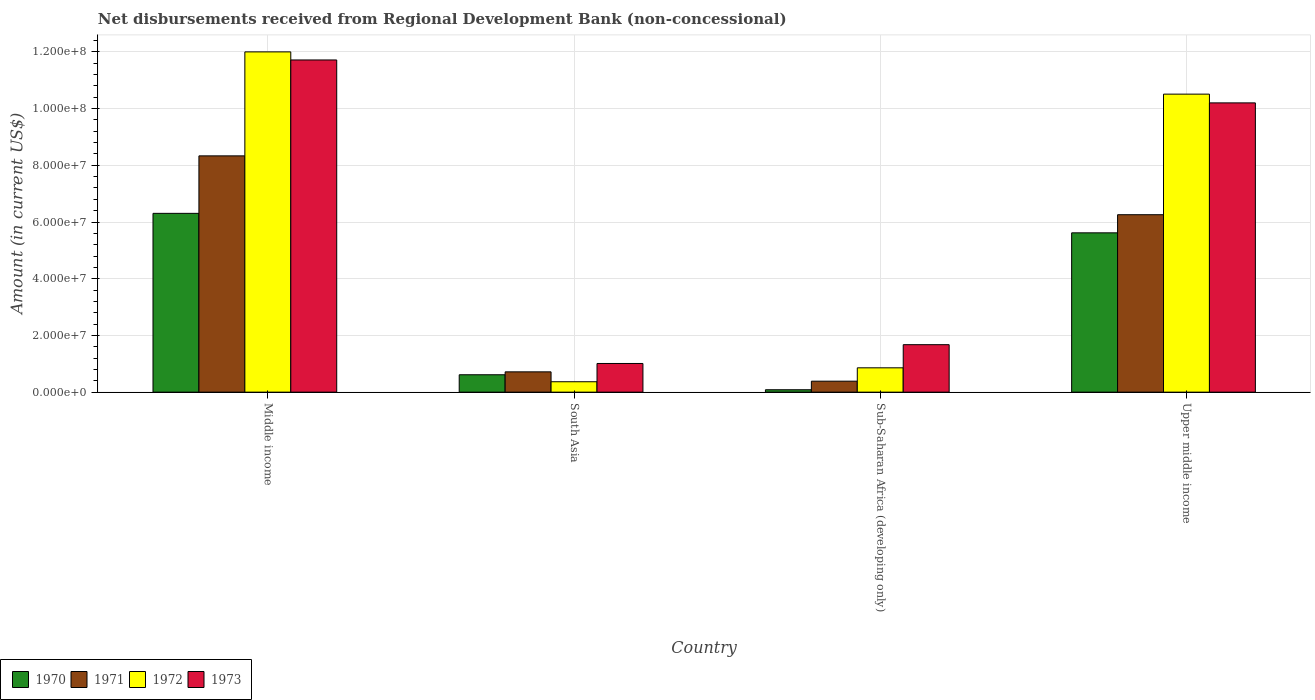How many groups of bars are there?
Provide a succinct answer. 4. Are the number of bars per tick equal to the number of legend labels?
Provide a short and direct response. Yes. Are the number of bars on each tick of the X-axis equal?
Your answer should be compact. Yes. What is the label of the 1st group of bars from the left?
Your response must be concise. Middle income. What is the amount of disbursements received from Regional Development Bank in 1971 in Upper middle income?
Your response must be concise. 6.26e+07. Across all countries, what is the maximum amount of disbursements received from Regional Development Bank in 1971?
Your answer should be very brief. 8.33e+07. Across all countries, what is the minimum amount of disbursements received from Regional Development Bank in 1973?
Provide a succinct answer. 1.01e+07. In which country was the amount of disbursements received from Regional Development Bank in 1973 minimum?
Make the answer very short. South Asia. What is the total amount of disbursements received from Regional Development Bank in 1973 in the graph?
Your answer should be very brief. 2.46e+08. What is the difference between the amount of disbursements received from Regional Development Bank in 1971 in South Asia and that in Upper middle income?
Give a very brief answer. -5.54e+07. What is the difference between the amount of disbursements received from Regional Development Bank in 1970 in Sub-Saharan Africa (developing only) and the amount of disbursements received from Regional Development Bank in 1973 in South Asia?
Your response must be concise. -9.26e+06. What is the average amount of disbursements received from Regional Development Bank in 1970 per country?
Ensure brevity in your answer.  3.16e+07. What is the difference between the amount of disbursements received from Regional Development Bank of/in 1970 and amount of disbursements received from Regional Development Bank of/in 1971 in Middle income?
Your response must be concise. -2.03e+07. In how many countries, is the amount of disbursements received from Regional Development Bank in 1971 greater than 40000000 US$?
Keep it short and to the point. 2. What is the ratio of the amount of disbursements received from Regional Development Bank in 1972 in Middle income to that in South Asia?
Make the answer very short. 32.71. Is the difference between the amount of disbursements received from Regional Development Bank in 1970 in Middle income and South Asia greater than the difference between the amount of disbursements received from Regional Development Bank in 1971 in Middle income and South Asia?
Your response must be concise. No. What is the difference between the highest and the second highest amount of disbursements received from Regional Development Bank in 1973?
Provide a short and direct response. 1.51e+07. What is the difference between the highest and the lowest amount of disbursements received from Regional Development Bank in 1973?
Give a very brief answer. 1.07e+08. Is the sum of the amount of disbursements received from Regional Development Bank in 1973 in South Asia and Sub-Saharan Africa (developing only) greater than the maximum amount of disbursements received from Regional Development Bank in 1971 across all countries?
Your response must be concise. No. What does the 4th bar from the left in Sub-Saharan Africa (developing only) represents?
Your answer should be compact. 1973. Is it the case that in every country, the sum of the amount of disbursements received from Regional Development Bank in 1973 and amount of disbursements received from Regional Development Bank in 1972 is greater than the amount of disbursements received from Regional Development Bank in 1971?
Ensure brevity in your answer.  Yes. How many bars are there?
Make the answer very short. 16. Are the values on the major ticks of Y-axis written in scientific E-notation?
Make the answer very short. Yes. Does the graph contain grids?
Provide a short and direct response. Yes. What is the title of the graph?
Ensure brevity in your answer.  Net disbursements received from Regional Development Bank (non-concessional). What is the label or title of the Y-axis?
Ensure brevity in your answer.  Amount (in current US$). What is the Amount (in current US$) of 1970 in Middle income?
Keep it short and to the point. 6.31e+07. What is the Amount (in current US$) in 1971 in Middle income?
Your answer should be compact. 8.33e+07. What is the Amount (in current US$) in 1972 in Middle income?
Provide a short and direct response. 1.20e+08. What is the Amount (in current US$) in 1973 in Middle income?
Give a very brief answer. 1.17e+08. What is the Amount (in current US$) in 1970 in South Asia?
Your answer should be very brief. 6.13e+06. What is the Amount (in current US$) in 1971 in South Asia?
Your response must be concise. 7.16e+06. What is the Amount (in current US$) of 1972 in South Asia?
Give a very brief answer. 3.67e+06. What is the Amount (in current US$) in 1973 in South Asia?
Offer a very short reply. 1.01e+07. What is the Amount (in current US$) in 1970 in Sub-Saharan Africa (developing only)?
Your answer should be very brief. 8.50e+05. What is the Amount (in current US$) of 1971 in Sub-Saharan Africa (developing only)?
Provide a short and direct response. 3.87e+06. What is the Amount (in current US$) in 1972 in Sub-Saharan Africa (developing only)?
Give a very brief answer. 8.58e+06. What is the Amount (in current US$) of 1973 in Sub-Saharan Africa (developing only)?
Give a very brief answer. 1.67e+07. What is the Amount (in current US$) in 1970 in Upper middle income?
Provide a succinct answer. 5.62e+07. What is the Amount (in current US$) of 1971 in Upper middle income?
Your response must be concise. 6.26e+07. What is the Amount (in current US$) in 1972 in Upper middle income?
Your response must be concise. 1.05e+08. What is the Amount (in current US$) of 1973 in Upper middle income?
Give a very brief answer. 1.02e+08. Across all countries, what is the maximum Amount (in current US$) of 1970?
Ensure brevity in your answer.  6.31e+07. Across all countries, what is the maximum Amount (in current US$) in 1971?
Ensure brevity in your answer.  8.33e+07. Across all countries, what is the maximum Amount (in current US$) in 1972?
Give a very brief answer. 1.20e+08. Across all countries, what is the maximum Amount (in current US$) of 1973?
Your answer should be very brief. 1.17e+08. Across all countries, what is the minimum Amount (in current US$) of 1970?
Make the answer very short. 8.50e+05. Across all countries, what is the minimum Amount (in current US$) in 1971?
Offer a terse response. 3.87e+06. Across all countries, what is the minimum Amount (in current US$) in 1972?
Offer a very short reply. 3.67e+06. Across all countries, what is the minimum Amount (in current US$) in 1973?
Give a very brief answer. 1.01e+07. What is the total Amount (in current US$) of 1970 in the graph?
Your response must be concise. 1.26e+08. What is the total Amount (in current US$) in 1971 in the graph?
Keep it short and to the point. 1.57e+08. What is the total Amount (in current US$) of 1972 in the graph?
Provide a short and direct response. 2.37e+08. What is the total Amount (in current US$) of 1973 in the graph?
Your response must be concise. 2.46e+08. What is the difference between the Amount (in current US$) in 1970 in Middle income and that in South Asia?
Provide a succinct answer. 5.69e+07. What is the difference between the Amount (in current US$) of 1971 in Middle income and that in South Asia?
Your response must be concise. 7.62e+07. What is the difference between the Amount (in current US$) in 1972 in Middle income and that in South Asia?
Your response must be concise. 1.16e+08. What is the difference between the Amount (in current US$) of 1973 in Middle income and that in South Asia?
Your answer should be very brief. 1.07e+08. What is the difference between the Amount (in current US$) in 1970 in Middle income and that in Sub-Saharan Africa (developing only)?
Give a very brief answer. 6.22e+07. What is the difference between the Amount (in current US$) in 1971 in Middle income and that in Sub-Saharan Africa (developing only)?
Your response must be concise. 7.95e+07. What is the difference between the Amount (in current US$) in 1972 in Middle income and that in Sub-Saharan Africa (developing only)?
Your response must be concise. 1.11e+08. What is the difference between the Amount (in current US$) in 1973 in Middle income and that in Sub-Saharan Africa (developing only)?
Your answer should be very brief. 1.00e+08. What is the difference between the Amount (in current US$) in 1970 in Middle income and that in Upper middle income?
Make the answer very short. 6.87e+06. What is the difference between the Amount (in current US$) of 1971 in Middle income and that in Upper middle income?
Make the answer very short. 2.08e+07. What is the difference between the Amount (in current US$) in 1972 in Middle income and that in Upper middle income?
Keep it short and to the point. 1.49e+07. What is the difference between the Amount (in current US$) of 1973 in Middle income and that in Upper middle income?
Your answer should be compact. 1.51e+07. What is the difference between the Amount (in current US$) of 1970 in South Asia and that in Sub-Saharan Africa (developing only)?
Your answer should be very brief. 5.28e+06. What is the difference between the Amount (in current US$) in 1971 in South Asia and that in Sub-Saharan Africa (developing only)?
Offer a very short reply. 3.29e+06. What is the difference between the Amount (in current US$) of 1972 in South Asia and that in Sub-Saharan Africa (developing only)?
Give a very brief answer. -4.91e+06. What is the difference between the Amount (in current US$) of 1973 in South Asia and that in Sub-Saharan Africa (developing only)?
Your answer should be compact. -6.63e+06. What is the difference between the Amount (in current US$) in 1970 in South Asia and that in Upper middle income?
Give a very brief answer. -5.01e+07. What is the difference between the Amount (in current US$) in 1971 in South Asia and that in Upper middle income?
Offer a terse response. -5.54e+07. What is the difference between the Amount (in current US$) of 1972 in South Asia and that in Upper middle income?
Make the answer very short. -1.01e+08. What is the difference between the Amount (in current US$) of 1973 in South Asia and that in Upper middle income?
Offer a very short reply. -9.19e+07. What is the difference between the Amount (in current US$) of 1970 in Sub-Saharan Africa (developing only) and that in Upper middle income?
Offer a very short reply. -5.53e+07. What is the difference between the Amount (in current US$) of 1971 in Sub-Saharan Africa (developing only) and that in Upper middle income?
Ensure brevity in your answer.  -5.87e+07. What is the difference between the Amount (in current US$) of 1972 in Sub-Saharan Africa (developing only) and that in Upper middle income?
Keep it short and to the point. -9.65e+07. What is the difference between the Amount (in current US$) in 1973 in Sub-Saharan Africa (developing only) and that in Upper middle income?
Offer a terse response. -8.53e+07. What is the difference between the Amount (in current US$) in 1970 in Middle income and the Amount (in current US$) in 1971 in South Asia?
Your answer should be compact. 5.59e+07. What is the difference between the Amount (in current US$) of 1970 in Middle income and the Amount (in current US$) of 1972 in South Asia?
Ensure brevity in your answer.  5.94e+07. What is the difference between the Amount (in current US$) of 1970 in Middle income and the Amount (in current US$) of 1973 in South Asia?
Make the answer very short. 5.29e+07. What is the difference between the Amount (in current US$) of 1971 in Middle income and the Amount (in current US$) of 1972 in South Asia?
Ensure brevity in your answer.  7.97e+07. What is the difference between the Amount (in current US$) in 1971 in Middle income and the Amount (in current US$) in 1973 in South Asia?
Keep it short and to the point. 7.32e+07. What is the difference between the Amount (in current US$) of 1972 in Middle income and the Amount (in current US$) of 1973 in South Asia?
Give a very brief answer. 1.10e+08. What is the difference between the Amount (in current US$) of 1970 in Middle income and the Amount (in current US$) of 1971 in Sub-Saharan Africa (developing only)?
Ensure brevity in your answer.  5.92e+07. What is the difference between the Amount (in current US$) in 1970 in Middle income and the Amount (in current US$) in 1972 in Sub-Saharan Africa (developing only)?
Give a very brief answer. 5.45e+07. What is the difference between the Amount (in current US$) in 1970 in Middle income and the Amount (in current US$) in 1973 in Sub-Saharan Africa (developing only)?
Make the answer very short. 4.63e+07. What is the difference between the Amount (in current US$) of 1971 in Middle income and the Amount (in current US$) of 1972 in Sub-Saharan Africa (developing only)?
Offer a terse response. 7.47e+07. What is the difference between the Amount (in current US$) in 1971 in Middle income and the Amount (in current US$) in 1973 in Sub-Saharan Africa (developing only)?
Provide a succinct answer. 6.66e+07. What is the difference between the Amount (in current US$) in 1972 in Middle income and the Amount (in current US$) in 1973 in Sub-Saharan Africa (developing only)?
Keep it short and to the point. 1.03e+08. What is the difference between the Amount (in current US$) in 1970 in Middle income and the Amount (in current US$) in 1971 in Upper middle income?
Keep it short and to the point. 4.82e+05. What is the difference between the Amount (in current US$) in 1970 in Middle income and the Amount (in current US$) in 1972 in Upper middle income?
Your response must be concise. -4.20e+07. What is the difference between the Amount (in current US$) of 1970 in Middle income and the Amount (in current US$) of 1973 in Upper middle income?
Ensure brevity in your answer.  -3.90e+07. What is the difference between the Amount (in current US$) in 1971 in Middle income and the Amount (in current US$) in 1972 in Upper middle income?
Give a very brief answer. -2.18e+07. What is the difference between the Amount (in current US$) in 1971 in Middle income and the Amount (in current US$) in 1973 in Upper middle income?
Your response must be concise. -1.87e+07. What is the difference between the Amount (in current US$) in 1972 in Middle income and the Amount (in current US$) in 1973 in Upper middle income?
Provide a short and direct response. 1.80e+07. What is the difference between the Amount (in current US$) in 1970 in South Asia and the Amount (in current US$) in 1971 in Sub-Saharan Africa (developing only)?
Provide a short and direct response. 2.26e+06. What is the difference between the Amount (in current US$) of 1970 in South Asia and the Amount (in current US$) of 1972 in Sub-Saharan Africa (developing only)?
Provide a short and direct response. -2.45e+06. What is the difference between the Amount (in current US$) in 1970 in South Asia and the Amount (in current US$) in 1973 in Sub-Saharan Africa (developing only)?
Provide a succinct answer. -1.06e+07. What is the difference between the Amount (in current US$) in 1971 in South Asia and the Amount (in current US$) in 1972 in Sub-Saharan Africa (developing only)?
Provide a short and direct response. -1.42e+06. What is the difference between the Amount (in current US$) in 1971 in South Asia and the Amount (in current US$) in 1973 in Sub-Saharan Africa (developing only)?
Ensure brevity in your answer.  -9.58e+06. What is the difference between the Amount (in current US$) in 1972 in South Asia and the Amount (in current US$) in 1973 in Sub-Saharan Africa (developing only)?
Offer a very short reply. -1.31e+07. What is the difference between the Amount (in current US$) in 1970 in South Asia and the Amount (in current US$) in 1971 in Upper middle income?
Give a very brief answer. -5.64e+07. What is the difference between the Amount (in current US$) of 1970 in South Asia and the Amount (in current US$) of 1972 in Upper middle income?
Give a very brief answer. -9.90e+07. What is the difference between the Amount (in current US$) of 1970 in South Asia and the Amount (in current US$) of 1973 in Upper middle income?
Your answer should be very brief. -9.59e+07. What is the difference between the Amount (in current US$) of 1971 in South Asia and the Amount (in current US$) of 1972 in Upper middle income?
Offer a terse response. -9.79e+07. What is the difference between the Amount (in current US$) of 1971 in South Asia and the Amount (in current US$) of 1973 in Upper middle income?
Ensure brevity in your answer.  -9.49e+07. What is the difference between the Amount (in current US$) in 1972 in South Asia and the Amount (in current US$) in 1973 in Upper middle income?
Offer a terse response. -9.83e+07. What is the difference between the Amount (in current US$) in 1970 in Sub-Saharan Africa (developing only) and the Amount (in current US$) in 1971 in Upper middle income?
Your answer should be very brief. -6.17e+07. What is the difference between the Amount (in current US$) of 1970 in Sub-Saharan Africa (developing only) and the Amount (in current US$) of 1972 in Upper middle income?
Provide a short and direct response. -1.04e+08. What is the difference between the Amount (in current US$) in 1970 in Sub-Saharan Africa (developing only) and the Amount (in current US$) in 1973 in Upper middle income?
Your answer should be compact. -1.01e+08. What is the difference between the Amount (in current US$) of 1971 in Sub-Saharan Africa (developing only) and the Amount (in current US$) of 1972 in Upper middle income?
Ensure brevity in your answer.  -1.01e+08. What is the difference between the Amount (in current US$) of 1971 in Sub-Saharan Africa (developing only) and the Amount (in current US$) of 1973 in Upper middle income?
Your answer should be compact. -9.81e+07. What is the difference between the Amount (in current US$) in 1972 in Sub-Saharan Africa (developing only) and the Amount (in current US$) in 1973 in Upper middle income?
Ensure brevity in your answer.  -9.34e+07. What is the average Amount (in current US$) of 1970 per country?
Offer a terse response. 3.16e+07. What is the average Amount (in current US$) in 1971 per country?
Your answer should be very brief. 3.92e+07. What is the average Amount (in current US$) of 1972 per country?
Provide a succinct answer. 5.93e+07. What is the average Amount (in current US$) of 1973 per country?
Make the answer very short. 6.15e+07. What is the difference between the Amount (in current US$) in 1970 and Amount (in current US$) in 1971 in Middle income?
Your response must be concise. -2.03e+07. What is the difference between the Amount (in current US$) in 1970 and Amount (in current US$) in 1972 in Middle income?
Ensure brevity in your answer.  -5.69e+07. What is the difference between the Amount (in current US$) of 1970 and Amount (in current US$) of 1973 in Middle income?
Provide a short and direct response. -5.41e+07. What is the difference between the Amount (in current US$) of 1971 and Amount (in current US$) of 1972 in Middle income?
Ensure brevity in your answer.  -3.67e+07. What is the difference between the Amount (in current US$) in 1971 and Amount (in current US$) in 1973 in Middle income?
Keep it short and to the point. -3.38e+07. What is the difference between the Amount (in current US$) of 1972 and Amount (in current US$) of 1973 in Middle income?
Your response must be concise. 2.85e+06. What is the difference between the Amount (in current US$) of 1970 and Amount (in current US$) of 1971 in South Asia?
Offer a very short reply. -1.02e+06. What is the difference between the Amount (in current US$) in 1970 and Amount (in current US$) in 1972 in South Asia?
Give a very brief answer. 2.46e+06. What is the difference between the Amount (in current US$) of 1970 and Amount (in current US$) of 1973 in South Asia?
Make the answer very short. -3.98e+06. What is the difference between the Amount (in current US$) in 1971 and Amount (in current US$) in 1972 in South Asia?
Give a very brief answer. 3.49e+06. What is the difference between the Amount (in current US$) in 1971 and Amount (in current US$) in 1973 in South Asia?
Make the answer very short. -2.95e+06. What is the difference between the Amount (in current US$) of 1972 and Amount (in current US$) of 1973 in South Asia?
Your answer should be very brief. -6.44e+06. What is the difference between the Amount (in current US$) of 1970 and Amount (in current US$) of 1971 in Sub-Saharan Africa (developing only)?
Keep it short and to the point. -3.02e+06. What is the difference between the Amount (in current US$) of 1970 and Amount (in current US$) of 1972 in Sub-Saharan Africa (developing only)?
Offer a terse response. -7.73e+06. What is the difference between the Amount (in current US$) of 1970 and Amount (in current US$) of 1973 in Sub-Saharan Africa (developing only)?
Give a very brief answer. -1.59e+07. What is the difference between the Amount (in current US$) in 1971 and Amount (in current US$) in 1972 in Sub-Saharan Africa (developing only)?
Your answer should be compact. -4.71e+06. What is the difference between the Amount (in current US$) in 1971 and Amount (in current US$) in 1973 in Sub-Saharan Africa (developing only)?
Offer a terse response. -1.29e+07. What is the difference between the Amount (in current US$) of 1972 and Amount (in current US$) of 1973 in Sub-Saharan Africa (developing only)?
Give a very brief answer. -8.16e+06. What is the difference between the Amount (in current US$) in 1970 and Amount (in current US$) in 1971 in Upper middle income?
Offer a very short reply. -6.39e+06. What is the difference between the Amount (in current US$) in 1970 and Amount (in current US$) in 1972 in Upper middle income?
Make the answer very short. -4.89e+07. What is the difference between the Amount (in current US$) in 1970 and Amount (in current US$) in 1973 in Upper middle income?
Offer a terse response. -4.58e+07. What is the difference between the Amount (in current US$) in 1971 and Amount (in current US$) in 1972 in Upper middle income?
Provide a short and direct response. -4.25e+07. What is the difference between the Amount (in current US$) of 1971 and Amount (in current US$) of 1973 in Upper middle income?
Provide a short and direct response. -3.94e+07. What is the difference between the Amount (in current US$) of 1972 and Amount (in current US$) of 1973 in Upper middle income?
Offer a very short reply. 3.08e+06. What is the ratio of the Amount (in current US$) of 1970 in Middle income to that in South Asia?
Make the answer very short. 10.28. What is the ratio of the Amount (in current US$) in 1971 in Middle income to that in South Asia?
Ensure brevity in your answer.  11.64. What is the ratio of the Amount (in current US$) of 1972 in Middle income to that in South Asia?
Offer a very short reply. 32.71. What is the ratio of the Amount (in current US$) of 1973 in Middle income to that in South Asia?
Provide a succinct answer. 11.58. What is the ratio of the Amount (in current US$) of 1970 in Middle income to that in Sub-Saharan Africa (developing only)?
Your answer should be very brief. 74.18. What is the ratio of the Amount (in current US$) of 1971 in Middle income to that in Sub-Saharan Africa (developing only)?
Your response must be concise. 21.54. What is the ratio of the Amount (in current US$) of 1972 in Middle income to that in Sub-Saharan Africa (developing only)?
Offer a very short reply. 13.98. What is the ratio of the Amount (in current US$) of 1973 in Middle income to that in Sub-Saharan Africa (developing only)?
Your answer should be very brief. 7. What is the ratio of the Amount (in current US$) of 1970 in Middle income to that in Upper middle income?
Your response must be concise. 1.12. What is the ratio of the Amount (in current US$) in 1971 in Middle income to that in Upper middle income?
Offer a terse response. 1.33. What is the ratio of the Amount (in current US$) in 1972 in Middle income to that in Upper middle income?
Your response must be concise. 1.14. What is the ratio of the Amount (in current US$) of 1973 in Middle income to that in Upper middle income?
Provide a succinct answer. 1.15. What is the ratio of the Amount (in current US$) of 1970 in South Asia to that in Sub-Saharan Africa (developing only)?
Provide a succinct answer. 7.22. What is the ratio of the Amount (in current US$) in 1971 in South Asia to that in Sub-Saharan Africa (developing only)?
Make the answer very short. 1.85. What is the ratio of the Amount (in current US$) in 1972 in South Asia to that in Sub-Saharan Africa (developing only)?
Give a very brief answer. 0.43. What is the ratio of the Amount (in current US$) in 1973 in South Asia to that in Sub-Saharan Africa (developing only)?
Provide a short and direct response. 0.6. What is the ratio of the Amount (in current US$) in 1970 in South Asia to that in Upper middle income?
Offer a very short reply. 0.11. What is the ratio of the Amount (in current US$) in 1971 in South Asia to that in Upper middle income?
Give a very brief answer. 0.11. What is the ratio of the Amount (in current US$) in 1972 in South Asia to that in Upper middle income?
Your answer should be very brief. 0.03. What is the ratio of the Amount (in current US$) in 1973 in South Asia to that in Upper middle income?
Keep it short and to the point. 0.1. What is the ratio of the Amount (in current US$) of 1970 in Sub-Saharan Africa (developing only) to that in Upper middle income?
Your answer should be very brief. 0.02. What is the ratio of the Amount (in current US$) in 1971 in Sub-Saharan Africa (developing only) to that in Upper middle income?
Keep it short and to the point. 0.06. What is the ratio of the Amount (in current US$) in 1972 in Sub-Saharan Africa (developing only) to that in Upper middle income?
Your answer should be very brief. 0.08. What is the ratio of the Amount (in current US$) in 1973 in Sub-Saharan Africa (developing only) to that in Upper middle income?
Make the answer very short. 0.16. What is the difference between the highest and the second highest Amount (in current US$) of 1970?
Provide a succinct answer. 6.87e+06. What is the difference between the highest and the second highest Amount (in current US$) of 1971?
Ensure brevity in your answer.  2.08e+07. What is the difference between the highest and the second highest Amount (in current US$) in 1972?
Your answer should be compact. 1.49e+07. What is the difference between the highest and the second highest Amount (in current US$) in 1973?
Keep it short and to the point. 1.51e+07. What is the difference between the highest and the lowest Amount (in current US$) in 1970?
Make the answer very short. 6.22e+07. What is the difference between the highest and the lowest Amount (in current US$) in 1971?
Offer a very short reply. 7.95e+07. What is the difference between the highest and the lowest Amount (in current US$) in 1972?
Your answer should be very brief. 1.16e+08. What is the difference between the highest and the lowest Amount (in current US$) in 1973?
Give a very brief answer. 1.07e+08. 